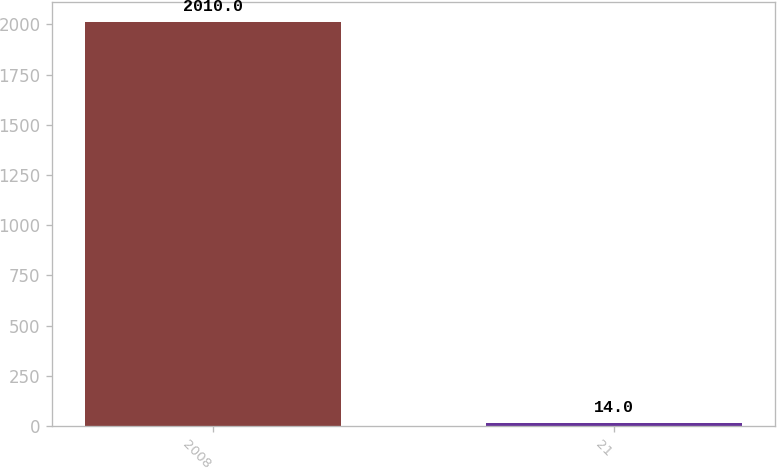<chart> <loc_0><loc_0><loc_500><loc_500><bar_chart><fcel>2008<fcel>21<nl><fcel>2010<fcel>14<nl></chart> 